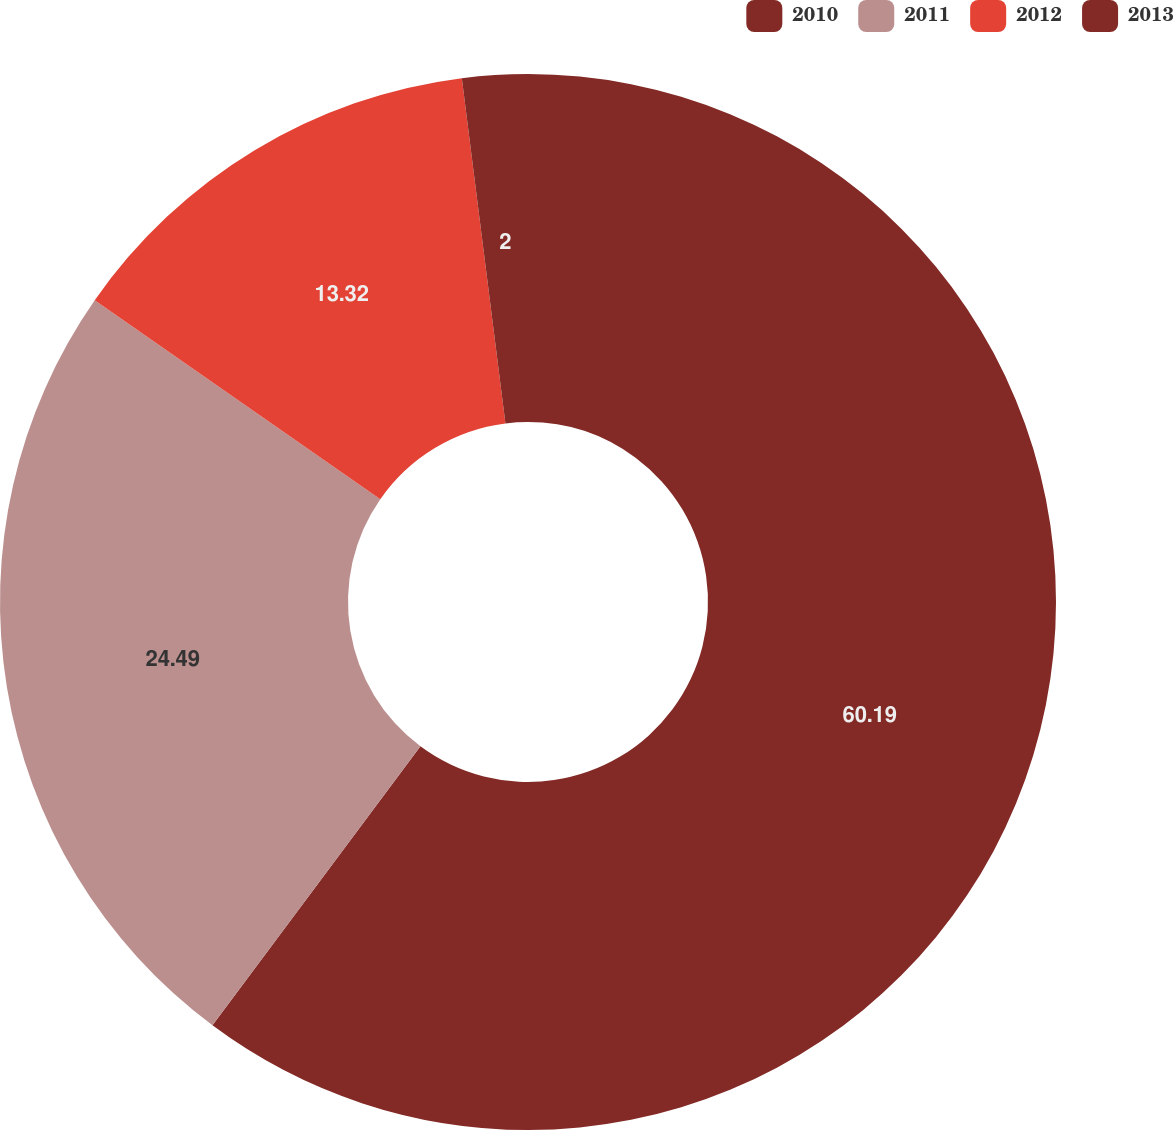<chart> <loc_0><loc_0><loc_500><loc_500><pie_chart><fcel>2010<fcel>2011<fcel>2012<fcel>2013<nl><fcel>60.2%<fcel>24.49%<fcel>13.32%<fcel>2.0%<nl></chart> 